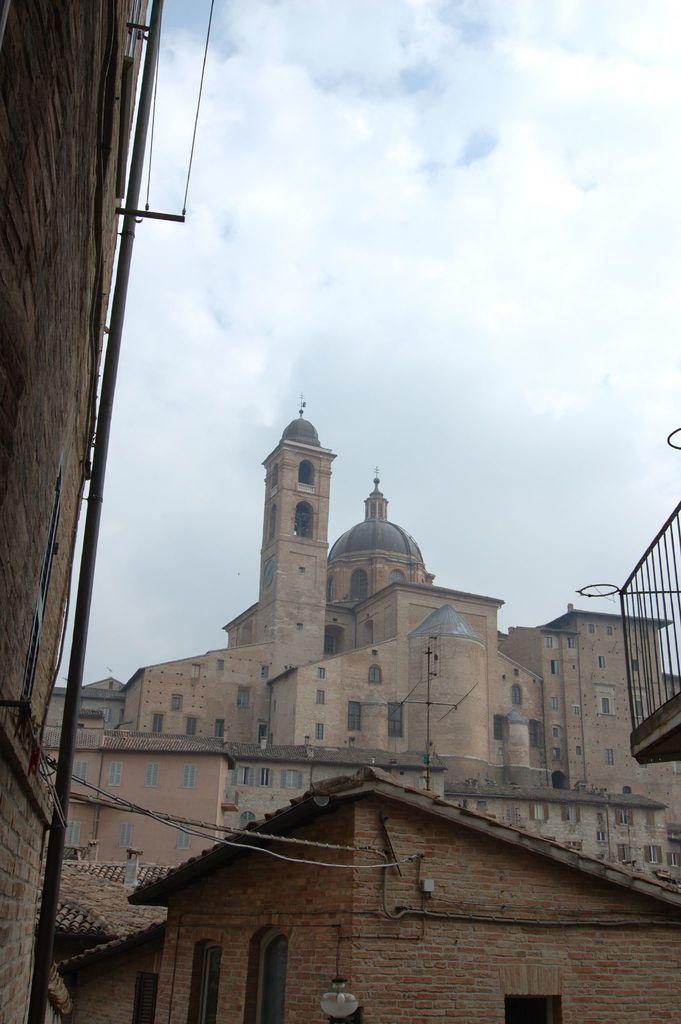Please provide a concise description of this image. In the picture we can see a house beside it, we can see a building wall with a pipe to it and to the house we can see a door and a light and behind the house we can see a building with windows and behind it we can see a palace and in the background we can see a sky with clouds. 